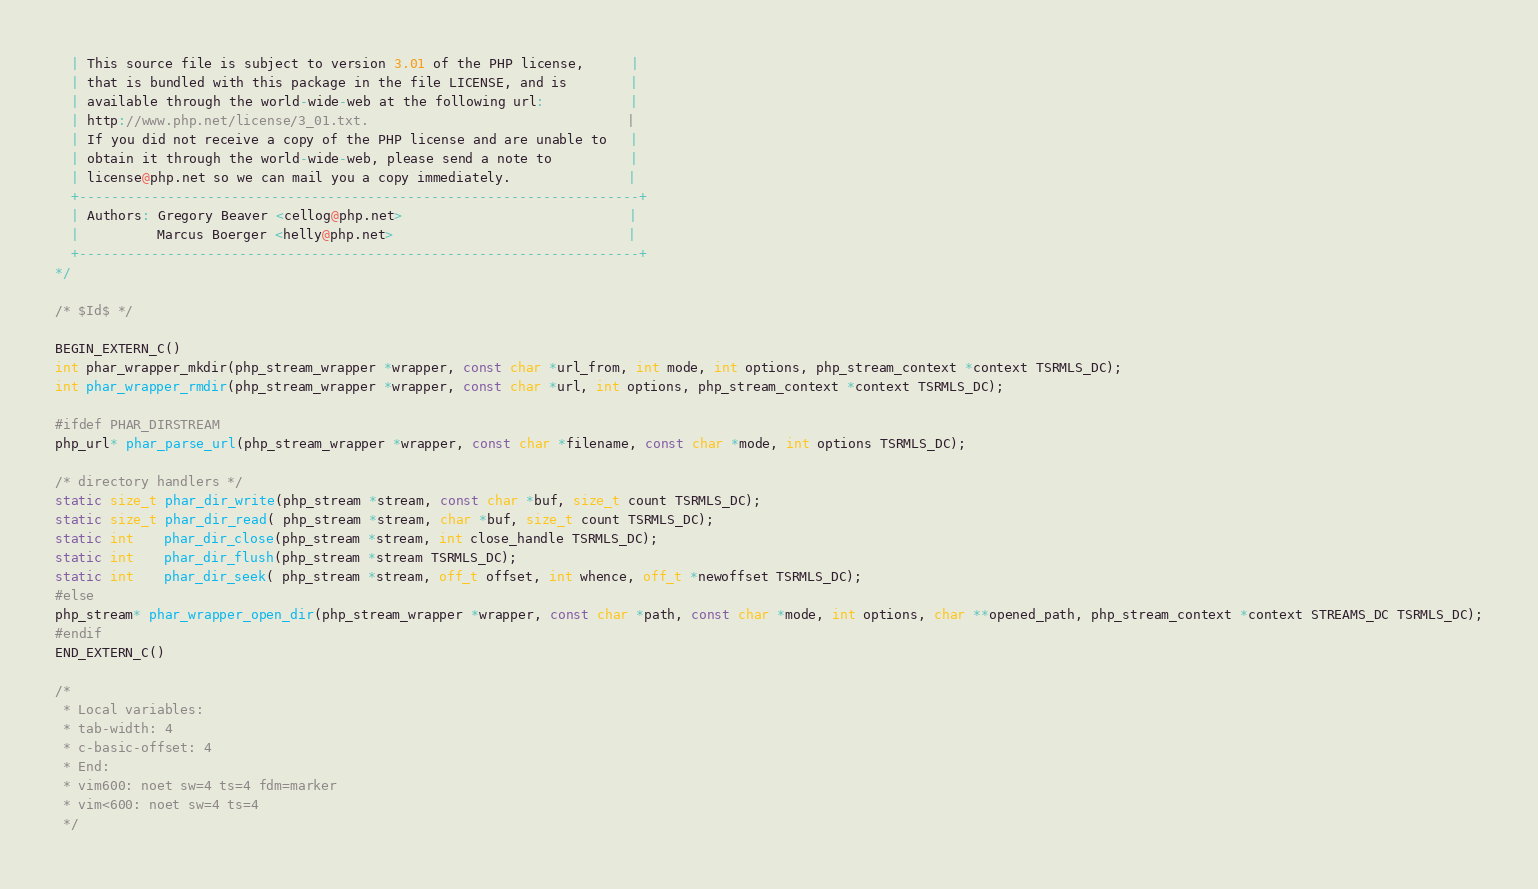<code> <loc_0><loc_0><loc_500><loc_500><_C_>  | This source file is subject to version 3.01 of the PHP license,      |
  | that is bundled with this package in the file LICENSE, and is        |
  | available through the world-wide-web at the following url:           |
  | http://www.php.net/license/3_01.txt.                                 |
  | If you did not receive a copy of the PHP license and are unable to   |
  | obtain it through the world-wide-web, please send a note to          |
  | license@php.net so we can mail you a copy immediately.               |
  +----------------------------------------------------------------------+
  | Authors: Gregory Beaver <cellog@php.net>                             |
  |          Marcus Boerger <helly@php.net>                              |
  +----------------------------------------------------------------------+
*/

/* $Id$ */

BEGIN_EXTERN_C()
int phar_wrapper_mkdir(php_stream_wrapper *wrapper, const char *url_from, int mode, int options, php_stream_context *context TSRMLS_DC);
int phar_wrapper_rmdir(php_stream_wrapper *wrapper, const char *url, int options, php_stream_context *context TSRMLS_DC);

#ifdef PHAR_DIRSTREAM
php_url* phar_parse_url(php_stream_wrapper *wrapper, const char *filename, const char *mode, int options TSRMLS_DC);

/* directory handlers */
static size_t phar_dir_write(php_stream *stream, const char *buf, size_t count TSRMLS_DC);
static size_t phar_dir_read( php_stream *stream, char *buf, size_t count TSRMLS_DC);
static int    phar_dir_close(php_stream *stream, int close_handle TSRMLS_DC);
static int    phar_dir_flush(php_stream *stream TSRMLS_DC);
static int    phar_dir_seek( php_stream *stream, off_t offset, int whence, off_t *newoffset TSRMLS_DC);
#else
php_stream* phar_wrapper_open_dir(php_stream_wrapper *wrapper, const char *path, const char *mode, int options, char **opened_path, php_stream_context *context STREAMS_DC TSRMLS_DC);
#endif
END_EXTERN_C()

/*
 * Local variables:
 * tab-width: 4
 * c-basic-offset: 4
 * End:
 * vim600: noet sw=4 ts=4 fdm=marker
 * vim<600: noet sw=4 ts=4
 */
</code> 